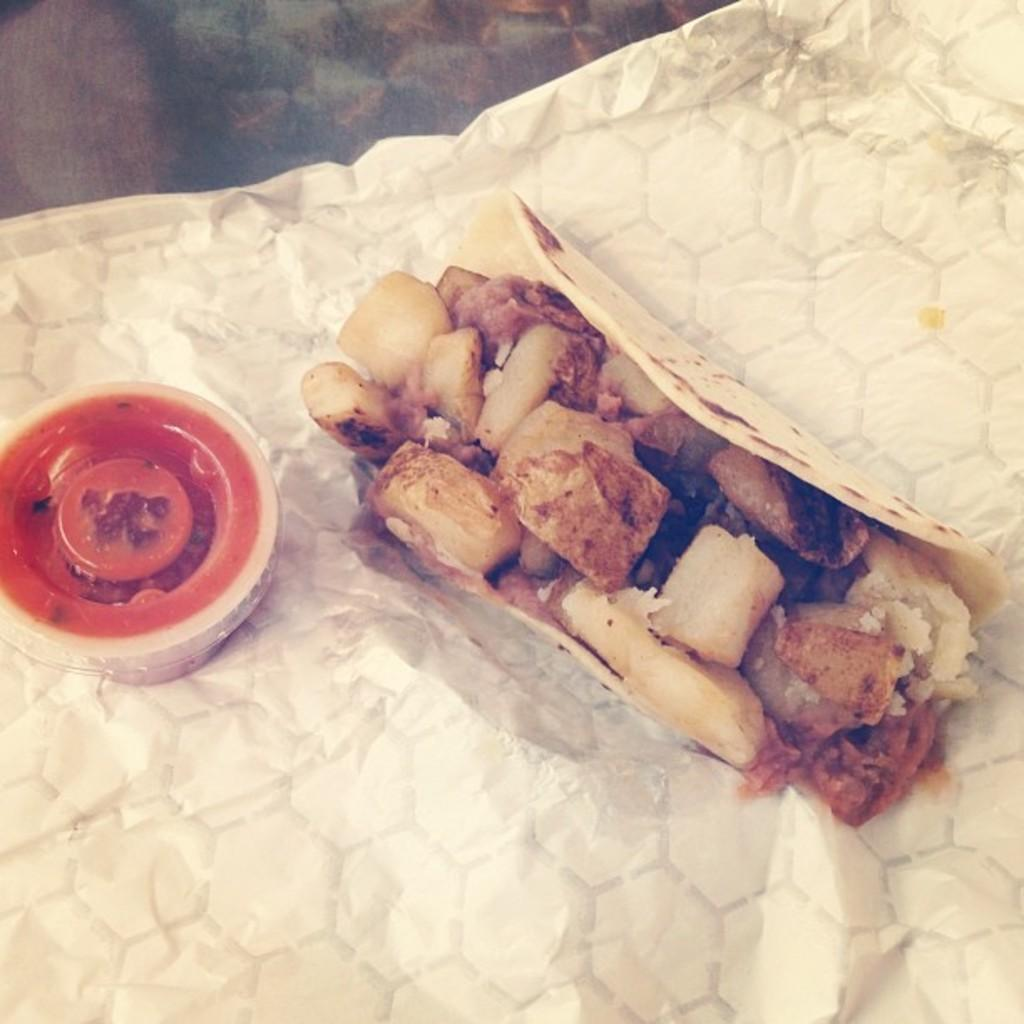What is present on the tissue in the image? There is a food item on the tissue. What can be found beside the food item? There is a small box with a red cap beside the food item. How many ducks are swimming in the drain near the food item? There are no ducks or drains present in the image. 